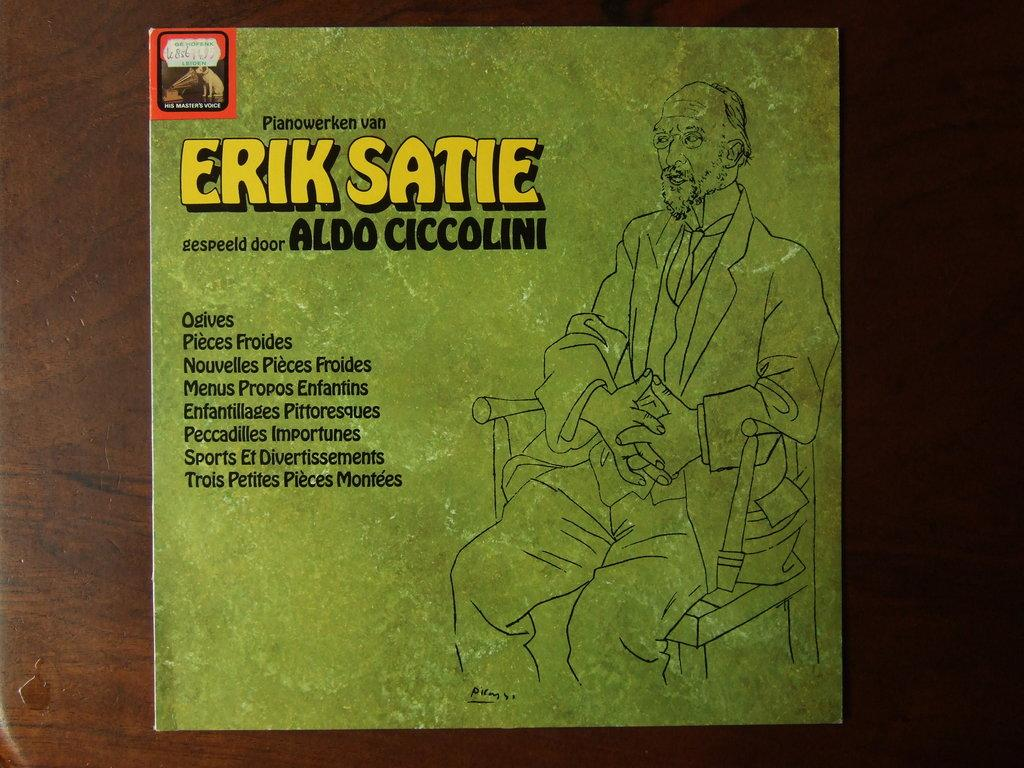<image>
Offer a succinct explanation of the picture presented. A green cover for Erik Satie and Aldo Ciccolini. 